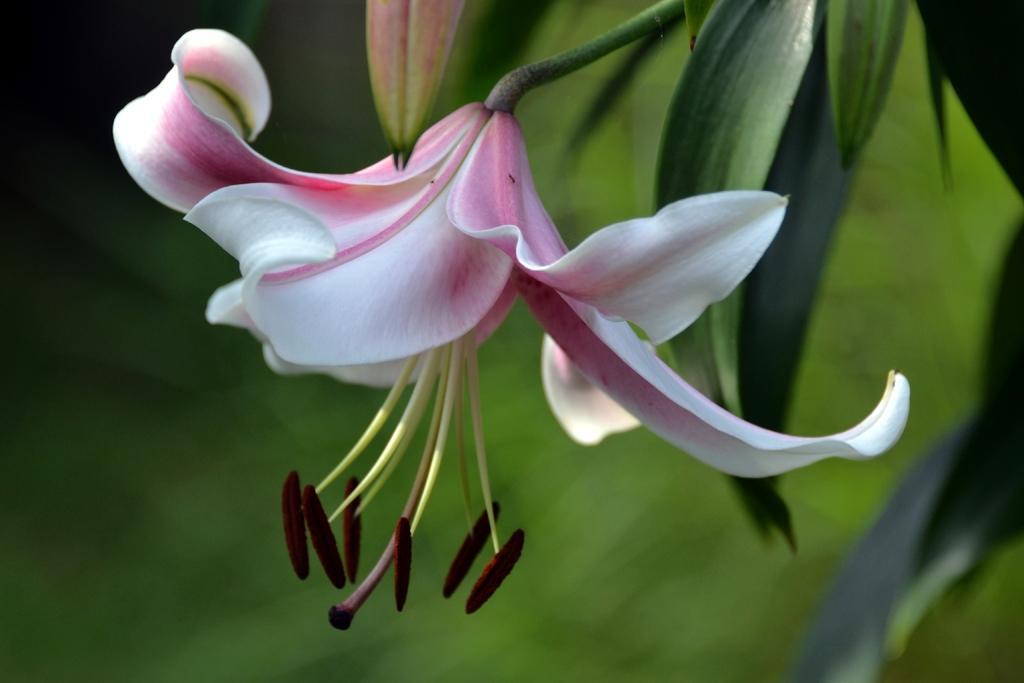How would you summarize this image in a sentence or two? In the center of the image there is a flower to the plant. 